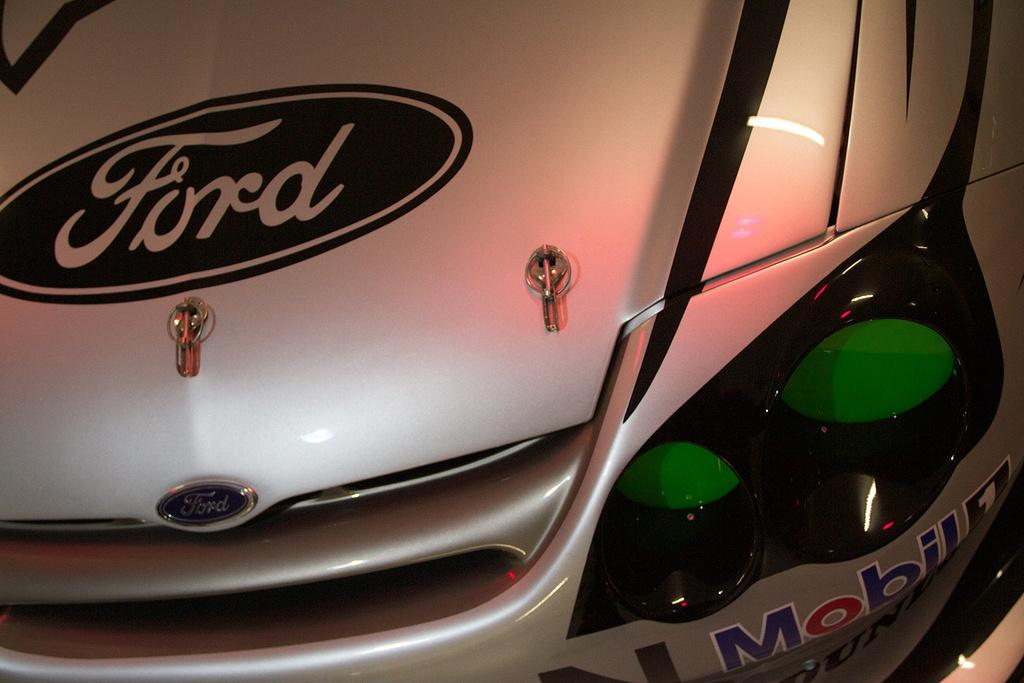What is the main subject of the image? The main subject of the image is a vehicle. What can be seen on the vehicle's surface? The vehicle has stickers and a logo on it. How many copies of coal are being carried by the vehicle in the image? There is no coal present in the image, and therefore no copies can be counted. What type of servant is depicted working on the vehicle in the image? There is no servant present in the image; it only features a vehicle with stickers and a logo. 